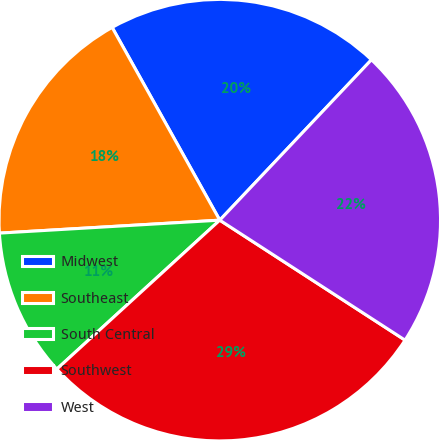<chart> <loc_0><loc_0><loc_500><loc_500><pie_chart><fcel>Midwest<fcel>Southeast<fcel>South Central<fcel>Southwest<fcel>West<nl><fcel>20.16%<fcel>17.83%<fcel>10.85%<fcel>29.07%<fcel>22.09%<nl></chart> 